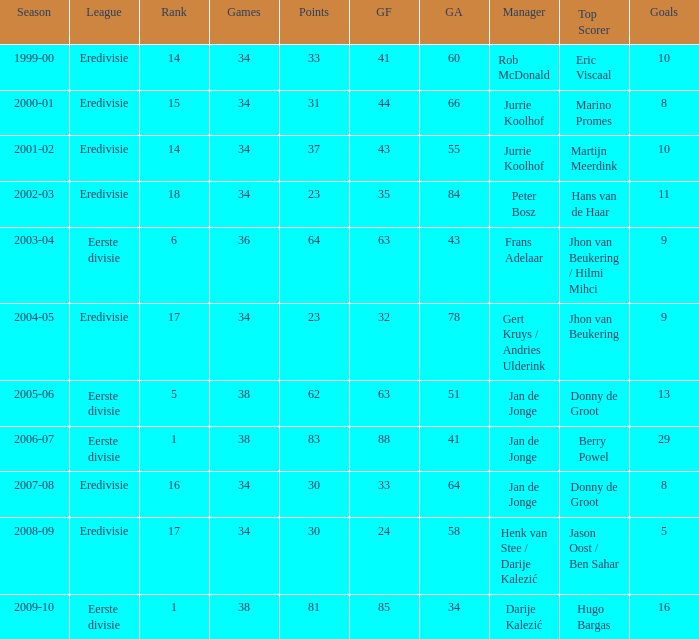Help me parse the entirety of this table. {'header': ['Season', 'League', 'Rank', 'Games', 'Points', 'GF', 'GA', 'Manager', 'Top Scorer', 'Goals'], 'rows': [['1999-00', 'Eredivisie', '14', '34', '33', '41', '60', 'Rob McDonald', 'Eric Viscaal', '10'], ['2000-01', 'Eredivisie', '15', '34', '31', '44', '66', 'Jurrie Koolhof', 'Marino Promes', '8'], ['2001-02', 'Eredivisie', '14', '34', '37', '43', '55', 'Jurrie Koolhof', 'Martijn Meerdink', '10'], ['2002-03', 'Eredivisie', '18', '34', '23', '35', '84', 'Peter Bosz', 'Hans van de Haar', '11'], ['2003-04', 'Eerste divisie', '6', '36', '64', '63', '43', 'Frans Adelaar', 'Jhon van Beukering / Hilmi Mihci', '9'], ['2004-05', 'Eredivisie', '17', '34', '23', '32', '78', 'Gert Kruys / Andries Ulderink', 'Jhon van Beukering', '9'], ['2005-06', 'Eerste divisie', '5', '38', '62', '63', '51', 'Jan de Jonge', 'Donny de Groot', '13'], ['2006-07', 'Eerste divisie', '1', '38', '83', '88', '41', 'Jan de Jonge', 'Berry Powel', '29'], ['2007-08', 'Eredivisie', '16', '34', '30', '33', '64', 'Jan de Jonge', 'Donny de Groot', '8'], ['2008-09', 'Eredivisie', '17', '34', '30', '24', '58', 'Henk van Stee / Darije Kalezić', 'Jason Oost / Ben Sahar', '5'], ['2009-10', 'Eerste divisie', '1', '38', '81', '85', '34', 'Darije Kalezić', 'Hugo Bargas', '16']]} Who has the most goals with a total of 41? Eric Viscaal. 